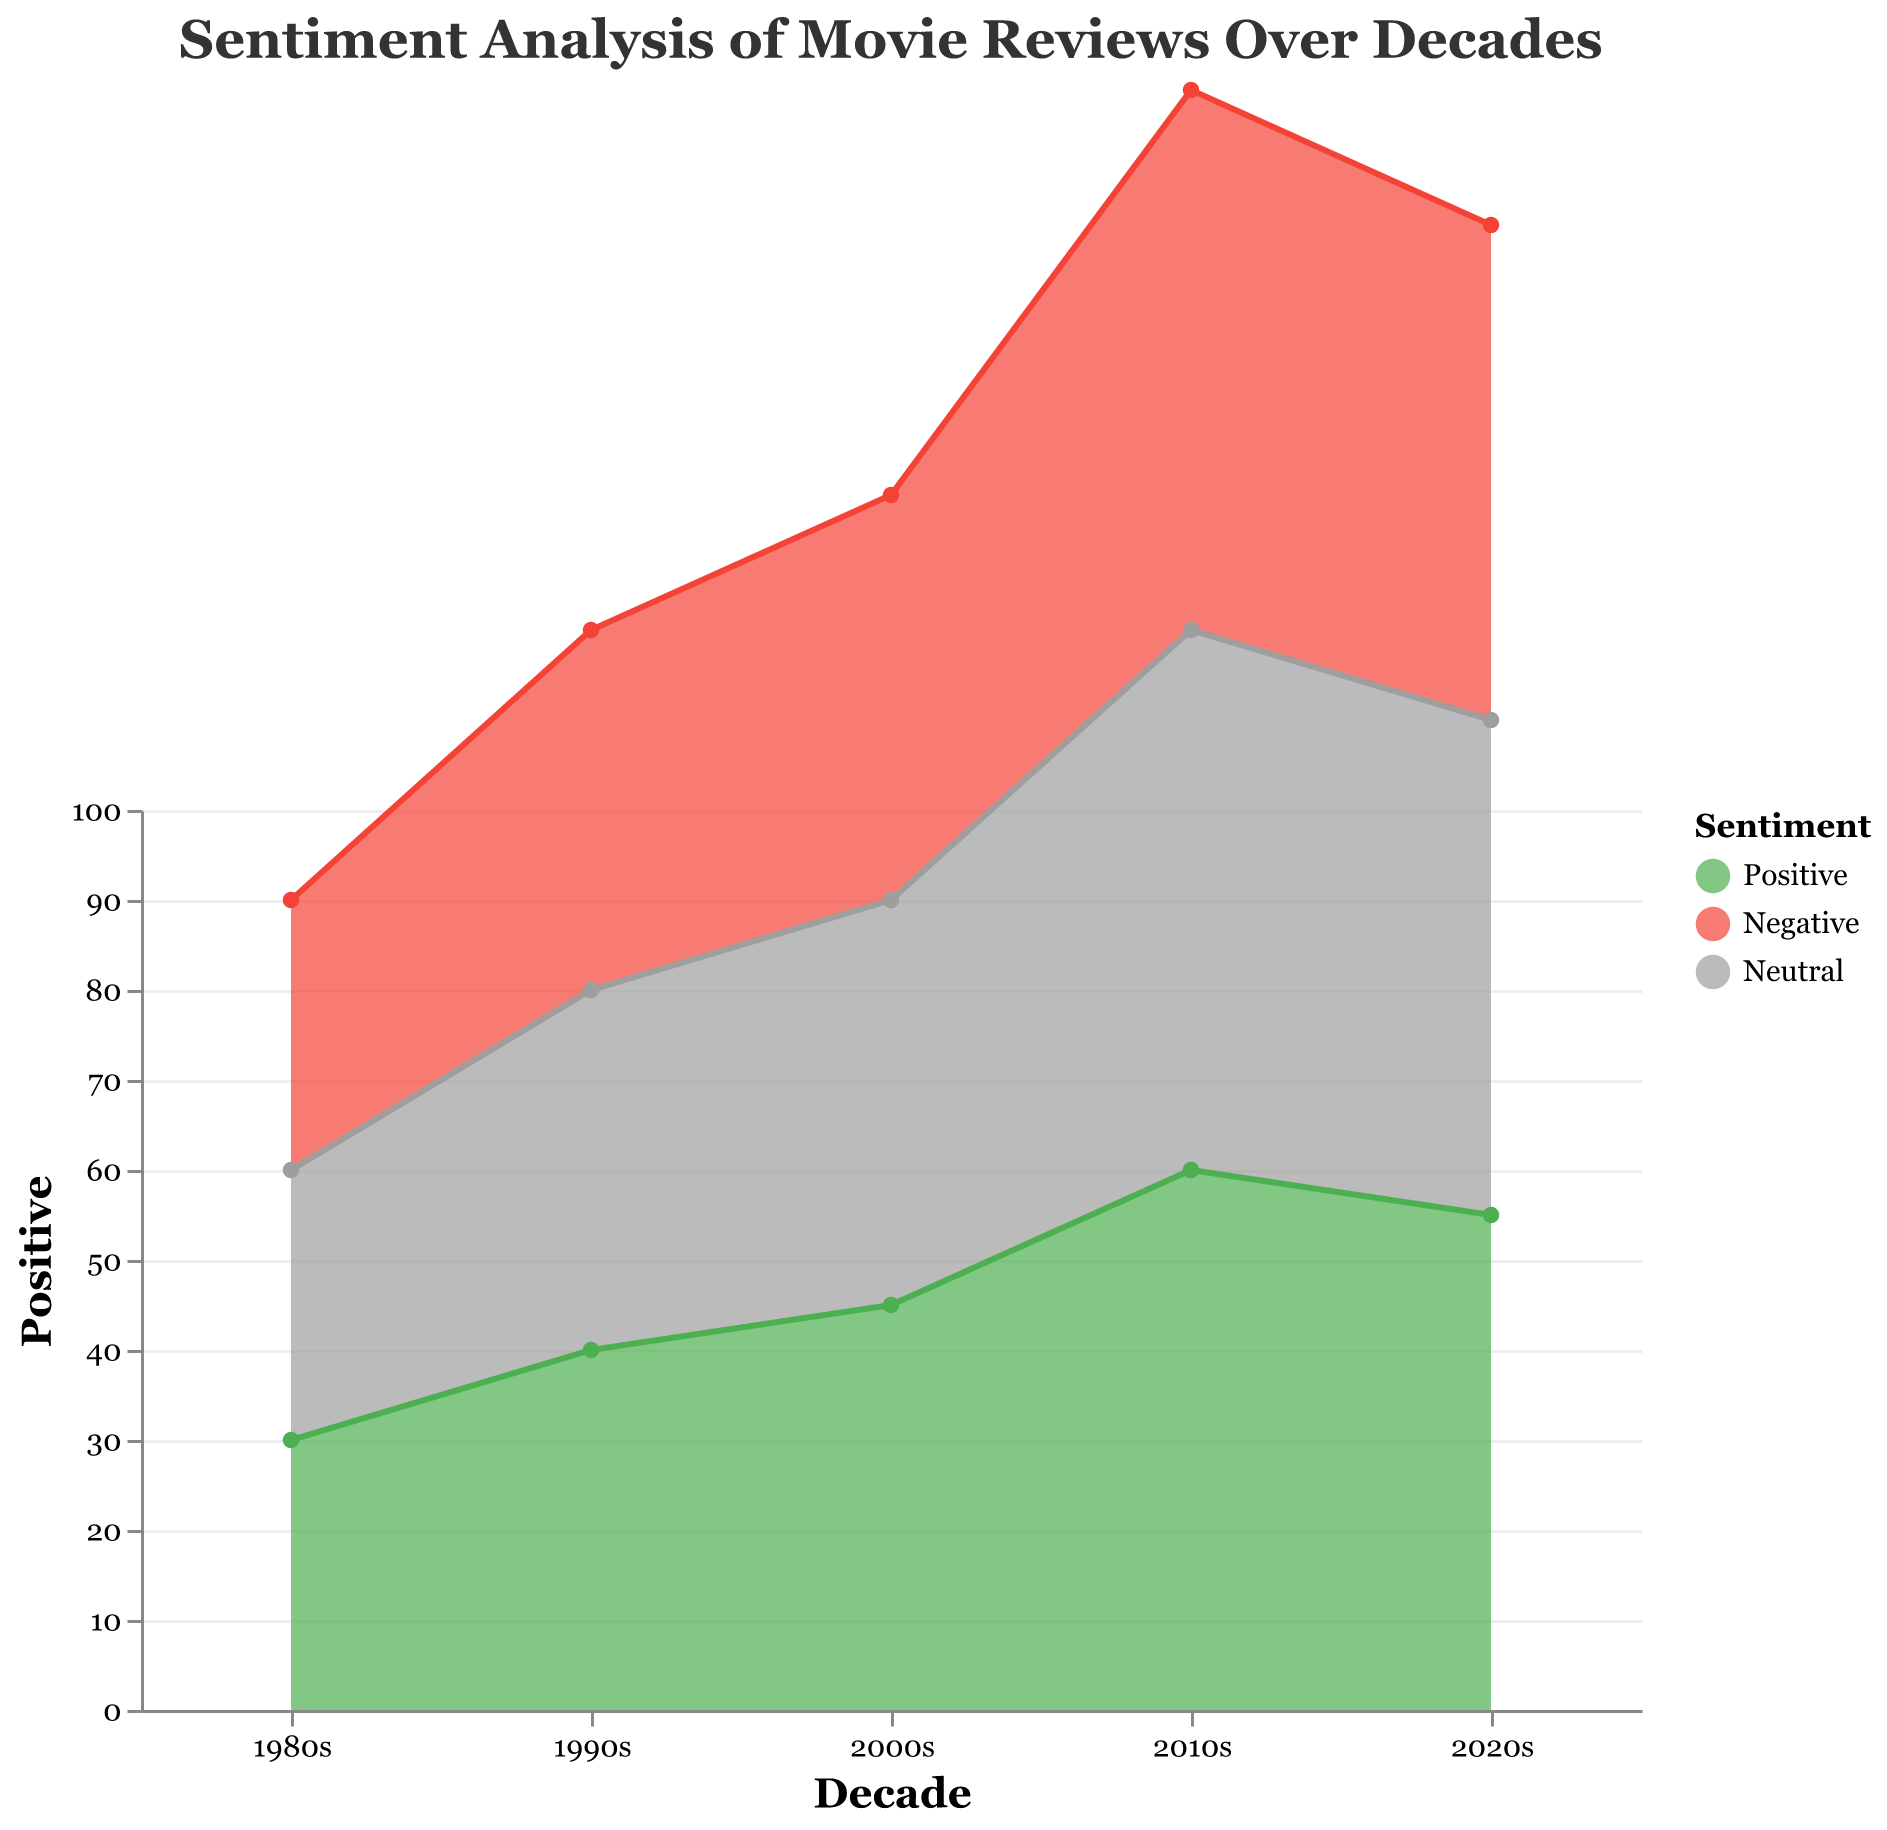What is the trend in positive sentiments from the 1980s to the 2020s? The chart shows an increasing trend in positive sentiments over the decades, starting from 30 in the 1980s and peaking at 60 in the 2010s, before slightly decreasing to 55 in the 2020s.
Answer: Increasing trend What was the highest percentage of negative sentiments in any decade? By observing the height of the area corresponding to negative sentiments, the highest percentage was in the 1980s at 50%.
Answer: 50% Which decade saw the biggest increase in positive sentiments compared to the previous decade? From the chart, the most significant increase in positive sentiments was between the 2000s and the 2010s, where it increased from 45% to 60%, an increase of 15 percentage points.
Answer: From 2000s to 2010s Compare the percentage of neutral sentiments in the 1990s and 2020s. Both the 1990s and the 2020s have the same percentage of neutral sentiments at 20% each.
Answer: Equal How did negative sentiments change from the 2010s to the 2020s? Negative sentiments increased from 25% in the 2010s to 30% in the 2020s, which is a 5 percentage point increase.
Answer: Increased by 5 points What is the noticeable trend of neutral sentiments over the decades? The neutral sentiment remains relatively stable at 20% for the 1980s, 1990s, and 2000s, then slightly decreases to 15% in the 2010s and stays constant till the 2020s.
Answer: Relatively stable, slight decrease in 2010s Which sentiment held the highest value in the 2010s, and what was the value? The positive sentiment held the highest value in the 2010s with 60%.
Answer: Positive, 60% In which decade did negative sentiments see the largest drop? Negative sentiments dropped the most from the 2000s to the 2010s, with a decrease from 35% to 25%, which is a 10 percentage point drop.
Answer: From 2000s to 2010s What can be said about the relationship between positive and negative sentiments over the decades? As positive sentiments increase, negative sentiments generally decrease across the decades, showing an inverse relationship.
Answer: Inverse relationship 